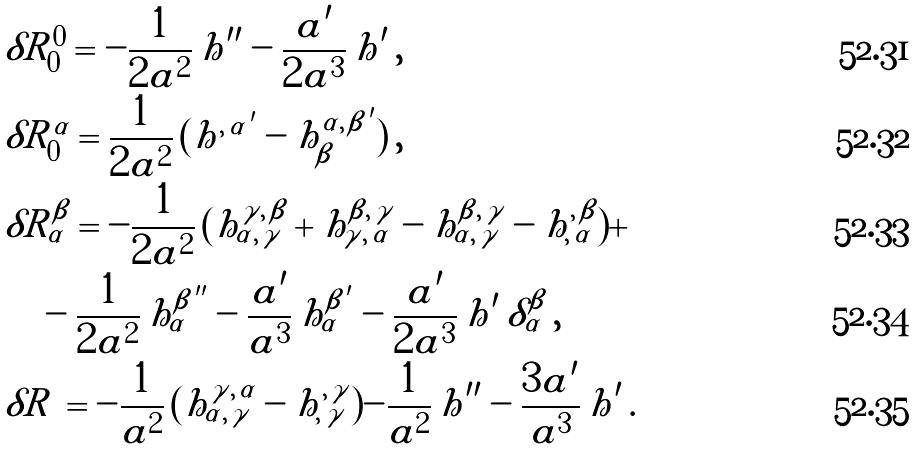<formula> <loc_0><loc_0><loc_500><loc_500>& \delta R _ { 0 } ^ { 0 } = - \frac { 1 } { 2 a ^ { 2 } } \, h ^ { \prime \prime } - \frac { a ^ { \prime } } { 2 a ^ { 3 } } \, h ^ { \prime } \, , \\ & \delta R _ { 0 } ^ { \alpha } = \frac { 1 } { 2 a ^ { 2 } } \, ( h ^ { , \, \alpha \, ^ { \prime } } - h _ { \beta } ^ { \alpha , \, \beta \, ^ { \prime } } ) \, , \\ & \delta R _ { \alpha } ^ { \beta } = - \frac { 1 } { 2 a ^ { 2 } } \, ( h ^ { \gamma , \, \beta } _ { \alpha , \, \gamma } + h ^ { \beta , \, \gamma } _ { \gamma , \, \alpha } - h ^ { \beta , \, \gamma } _ { \alpha , \, \gamma } - h ^ { , \, \beta } _ { , \, \alpha } ) + \\ & \quad - \frac { 1 } { 2 a ^ { 2 } } \, h _ { \alpha } ^ { \beta \, ^ { \prime \prime } } - \frac { a ^ { \prime } } { a ^ { 3 } } \, h _ { \alpha } ^ { \beta \, ^ { \prime } } - \frac { a ^ { \prime } } { 2 a ^ { 3 } } \, h ^ { \prime } \, \delta _ { \alpha } ^ { \beta } \, , \\ & \delta R \, = - \frac { 1 } { a ^ { 2 } } \, ( h ^ { \gamma , \, \alpha } _ { \alpha , \, \gamma } - h ^ { , \, \gamma } _ { , \, \gamma } ) - \frac { 1 } { a ^ { 2 } } \, h ^ { \prime \prime } - \frac { 3 a ^ { \prime } } { a ^ { 3 } } \, h ^ { \prime } \, .</formula> 